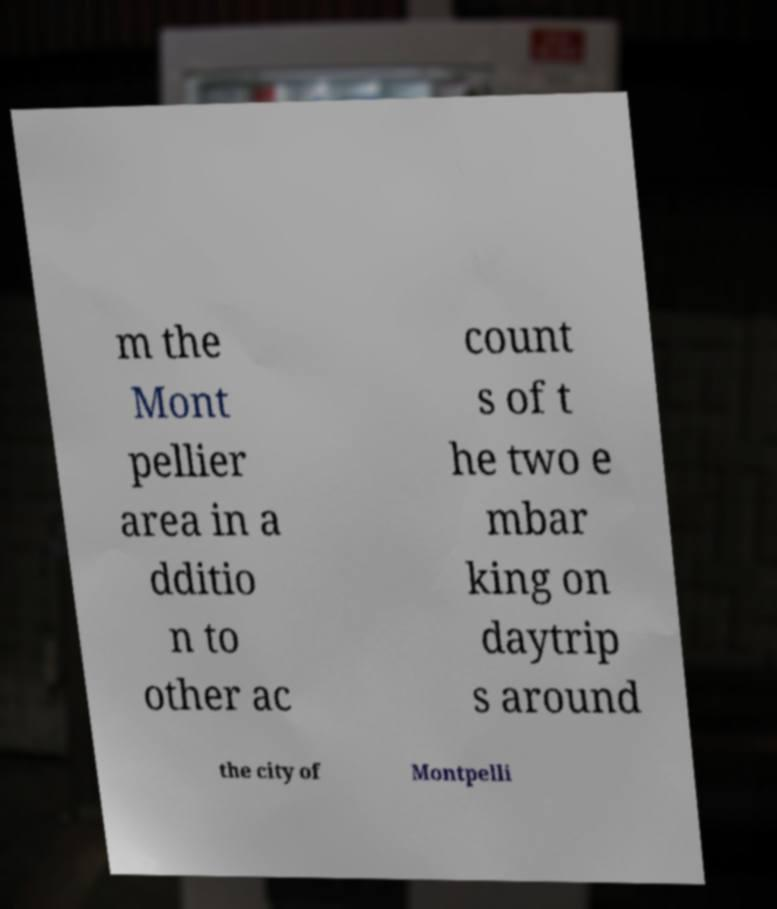What messages or text are displayed in this image? I need them in a readable, typed format. m the Mont pellier area in a dditio n to other ac count s of t he two e mbar king on daytrip s around the city of Montpelli 